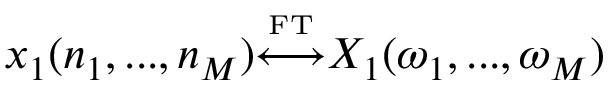Convert formula to latex. <formula><loc_0><loc_0><loc_500><loc_500>x _ { 1 } ( n _ { 1 } , \dots , n _ { M } ) { \overset { \underset { F T } { \longleftrightarrow } } X _ { 1 } ( \omega _ { 1 } , \dots , \omega _ { M } )</formula> 